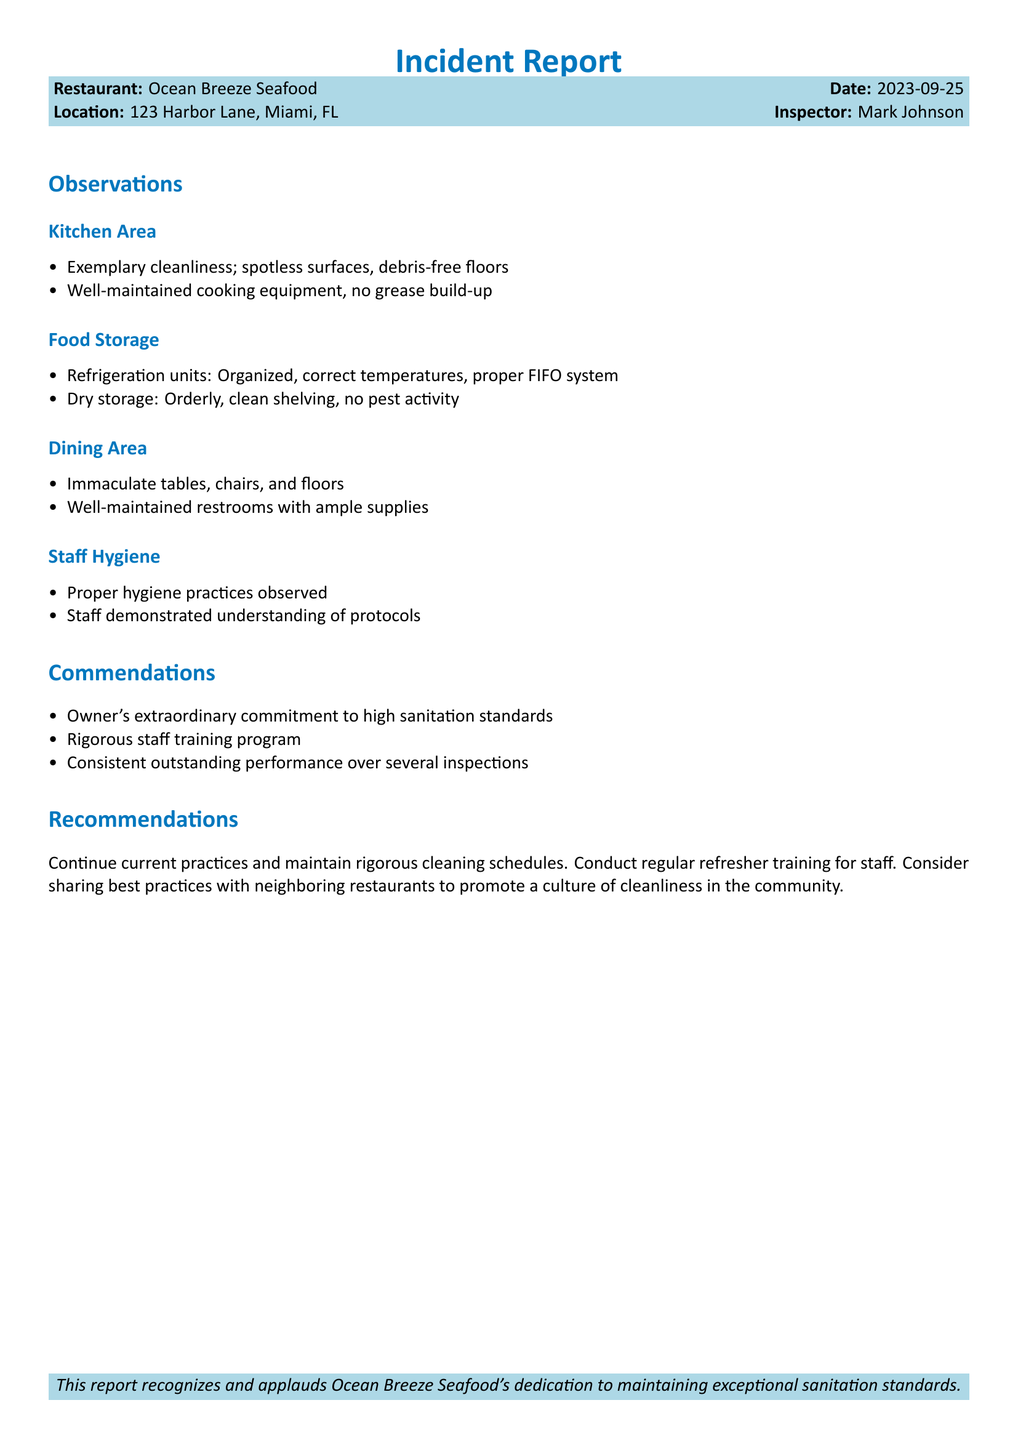What is the name of the restaurant? The restaurant's name is stated in the document header.
Answer: Ocean Breeze Seafood What was the date of the health inspection? The date of the health inspection is provided next to the restaurant's name.
Answer: 2023-09-25 Who was the inspector for this report? The inspector's name appears below the restaurant details.
Answer: Mark Johnson What specific area showed exemplary cleanliness? The document lists various areas and remarks on cleanliness.
Answer: Kitchen Area What system was noted for food storage? The report mentions an organized process for food management.
Answer: FIFO system What commendation was given for the owner's commitment? The report specifically acknowledges the owner's dedication.
Answer: Extraordinary commitment to high sanitation standards What is recommended for the staff's training? The document suggests a specific action regarding staff training.
Answer: Regular refresher training How would you summarize the dining area cleanliness? The report describes the dining area in overall terms.
Answer: Immaculate What was the recommendation for neighboring restaurants? The report includes a suggestion related to the community.
Answer: Sharing best practices 